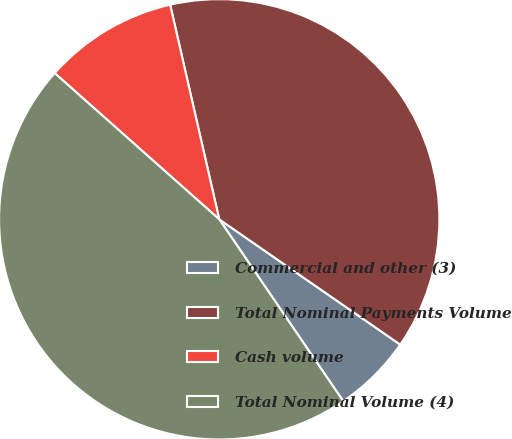Convert chart. <chart><loc_0><loc_0><loc_500><loc_500><pie_chart><fcel>Commercial and other (3)<fcel>Total Nominal Payments Volume<fcel>Cash volume<fcel>Total Nominal Volume (4)<nl><fcel>5.84%<fcel>38.21%<fcel>9.86%<fcel>46.08%<nl></chart> 